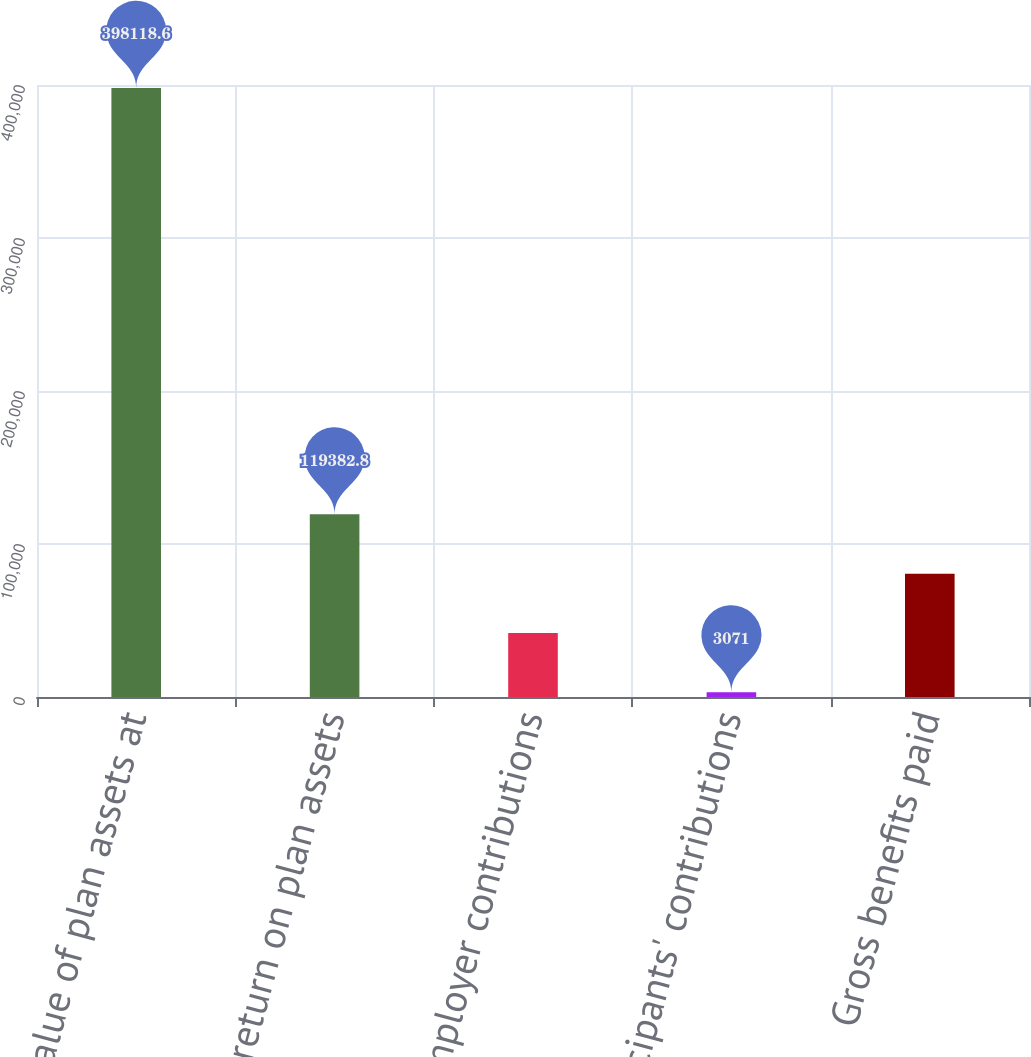<chart> <loc_0><loc_0><loc_500><loc_500><bar_chart><fcel>Fair Value of plan assets at<fcel>Actual return on plan assets<fcel>Employer contributions<fcel>Participants' contributions<fcel>Gross benefits paid<nl><fcel>398119<fcel>119383<fcel>41841.6<fcel>3071<fcel>80612.2<nl></chart> 